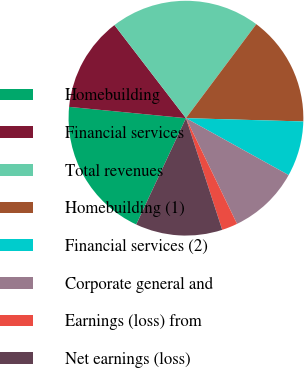Convert chart to OTSL. <chart><loc_0><loc_0><loc_500><loc_500><pie_chart><fcel>Homebuilding<fcel>Financial services<fcel>Total revenues<fcel>Homebuilding (1)<fcel>Financial services (2)<fcel>Corporate general and<fcel>Earnings (loss) from<fcel>Net earnings (loss)<nl><fcel>19.57%<fcel>13.04%<fcel>20.65%<fcel>15.22%<fcel>7.61%<fcel>9.78%<fcel>2.17%<fcel>11.96%<nl></chart> 